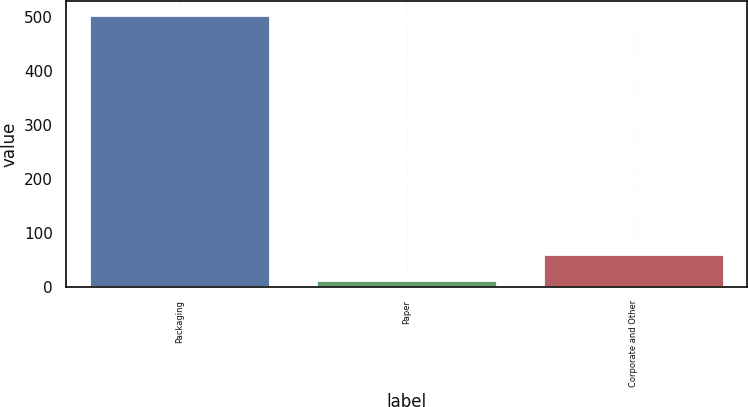Convert chart. <chart><loc_0><loc_0><loc_500><loc_500><bar_chart><fcel>Packaging<fcel>Paper<fcel>Corporate and Other<nl><fcel>504<fcel>12.6<fcel>61.74<nl></chart> 